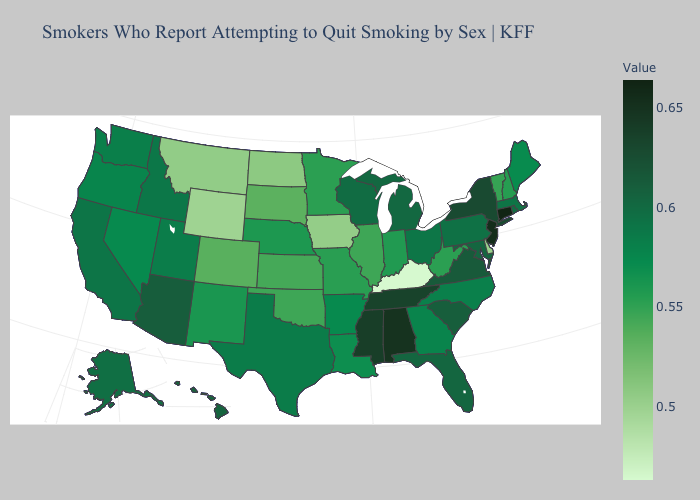Among the states that border Arkansas , which have the lowest value?
Quick response, please. Oklahoma. Does Ohio have the lowest value in the MidWest?
Concise answer only. No. Which states have the lowest value in the USA?
Short answer required. Kentucky. 